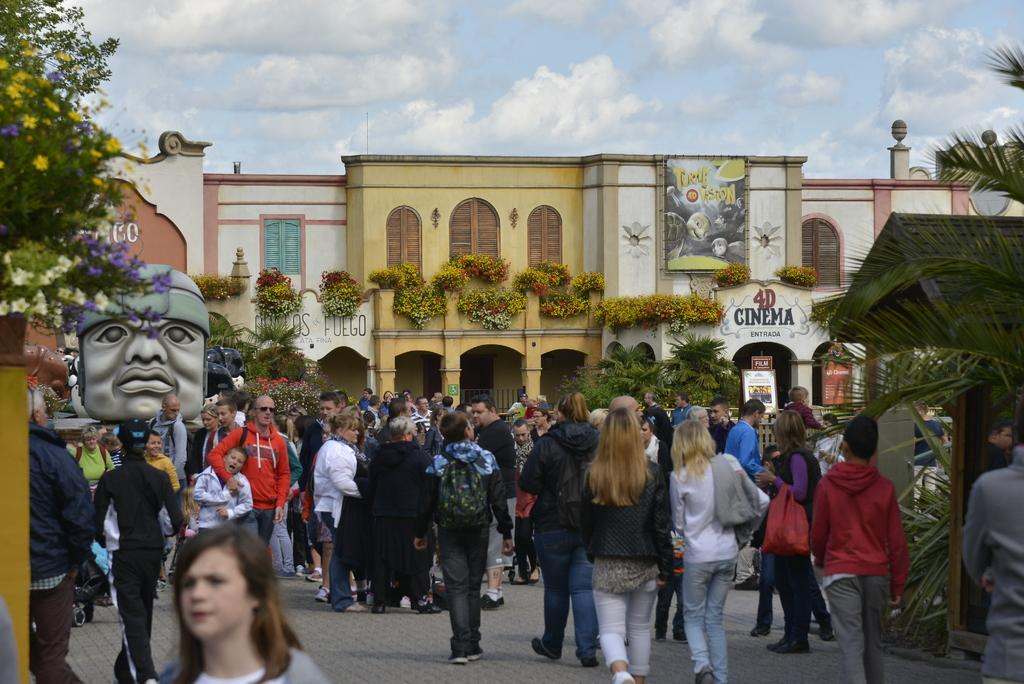Who is present in the image? There are people in the image. What are the people doing in the image? The people are walking on the streets. What can be seen in the background of the image? There is a building in the image. What is the chance of winning the lottery in the image? There is no information about the lottery or winning chances in the image. 